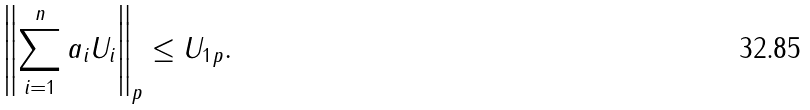<formula> <loc_0><loc_0><loc_500><loc_500>\left \| \sum _ { i = 1 } ^ { n } a _ { i } U _ { i } \right \| _ { p } \leq \| U _ { 1 } \| _ { p } .</formula> 